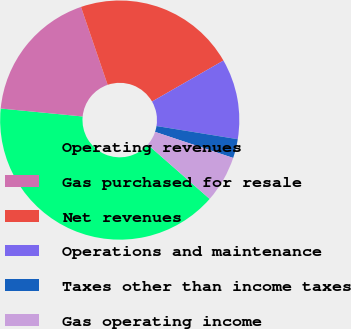<chart> <loc_0><loc_0><loc_500><loc_500><pie_chart><fcel>Operating revenues<fcel>Gas purchased for resale<fcel>Net revenues<fcel>Operations and maintenance<fcel>Taxes other than income taxes<fcel>Gas operating income<nl><fcel>40.09%<fcel>18.21%<fcel>21.96%<fcel>10.85%<fcel>2.57%<fcel>6.33%<nl></chart> 